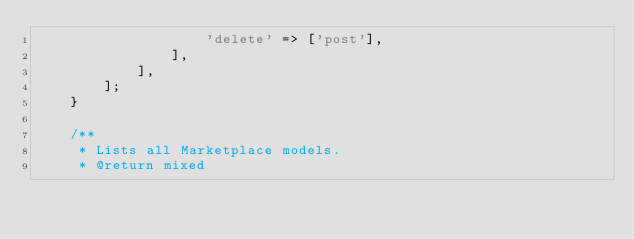Convert code to text. <code><loc_0><loc_0><loc_500><loc_500><_PHP_>                    'delete' => ['post'],
                ],
            ],
        ];
    }

    /**
     * Lists all Marketplace models.
     * @return mixed</code> 